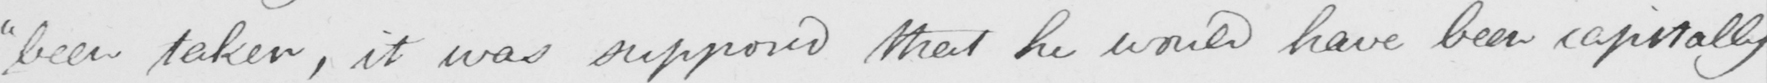Please transcribe the handwritten text in this image. " been taken , it was supposed that he would have been capitally 